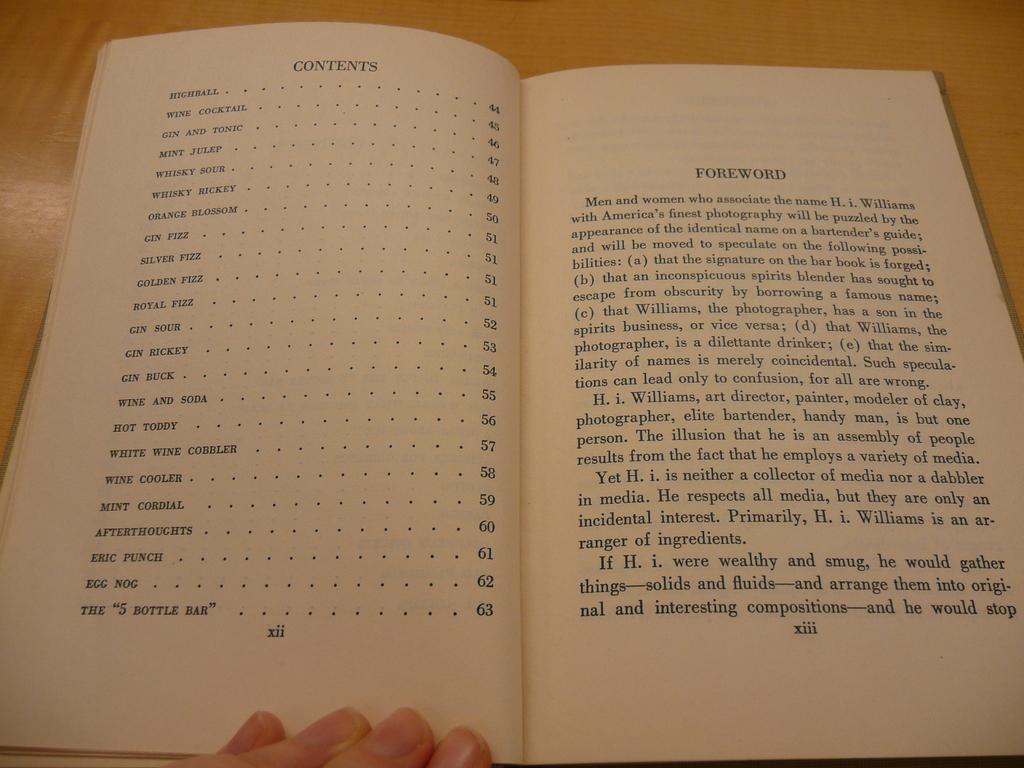What is the title of the page on the right side?
Keep it short and to the point. Foreword. 